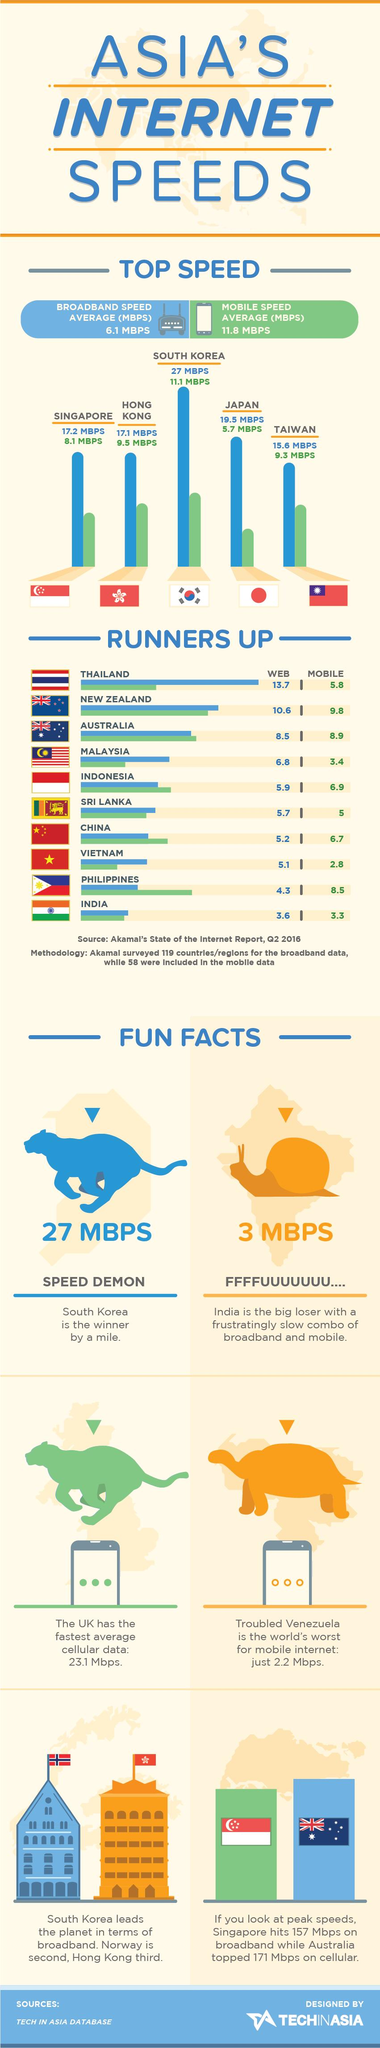Indicate a few pertinent items in this graphic. In Q2 2016, the average mobile internet speed in China was 6.7 Mbps. In the second quarter of 2016, the average broadband internet speed in Australia was 8.5 Mbps. In the second quarter of 2016, Japan had the second highest broadband speed among Asian countries. According to data from Q2 2016, South Korea had the highest broadband speed among all Asian countries. Hong Kong was the Asian country with the second highest mobile internet speed in the second quarter of 2016. 